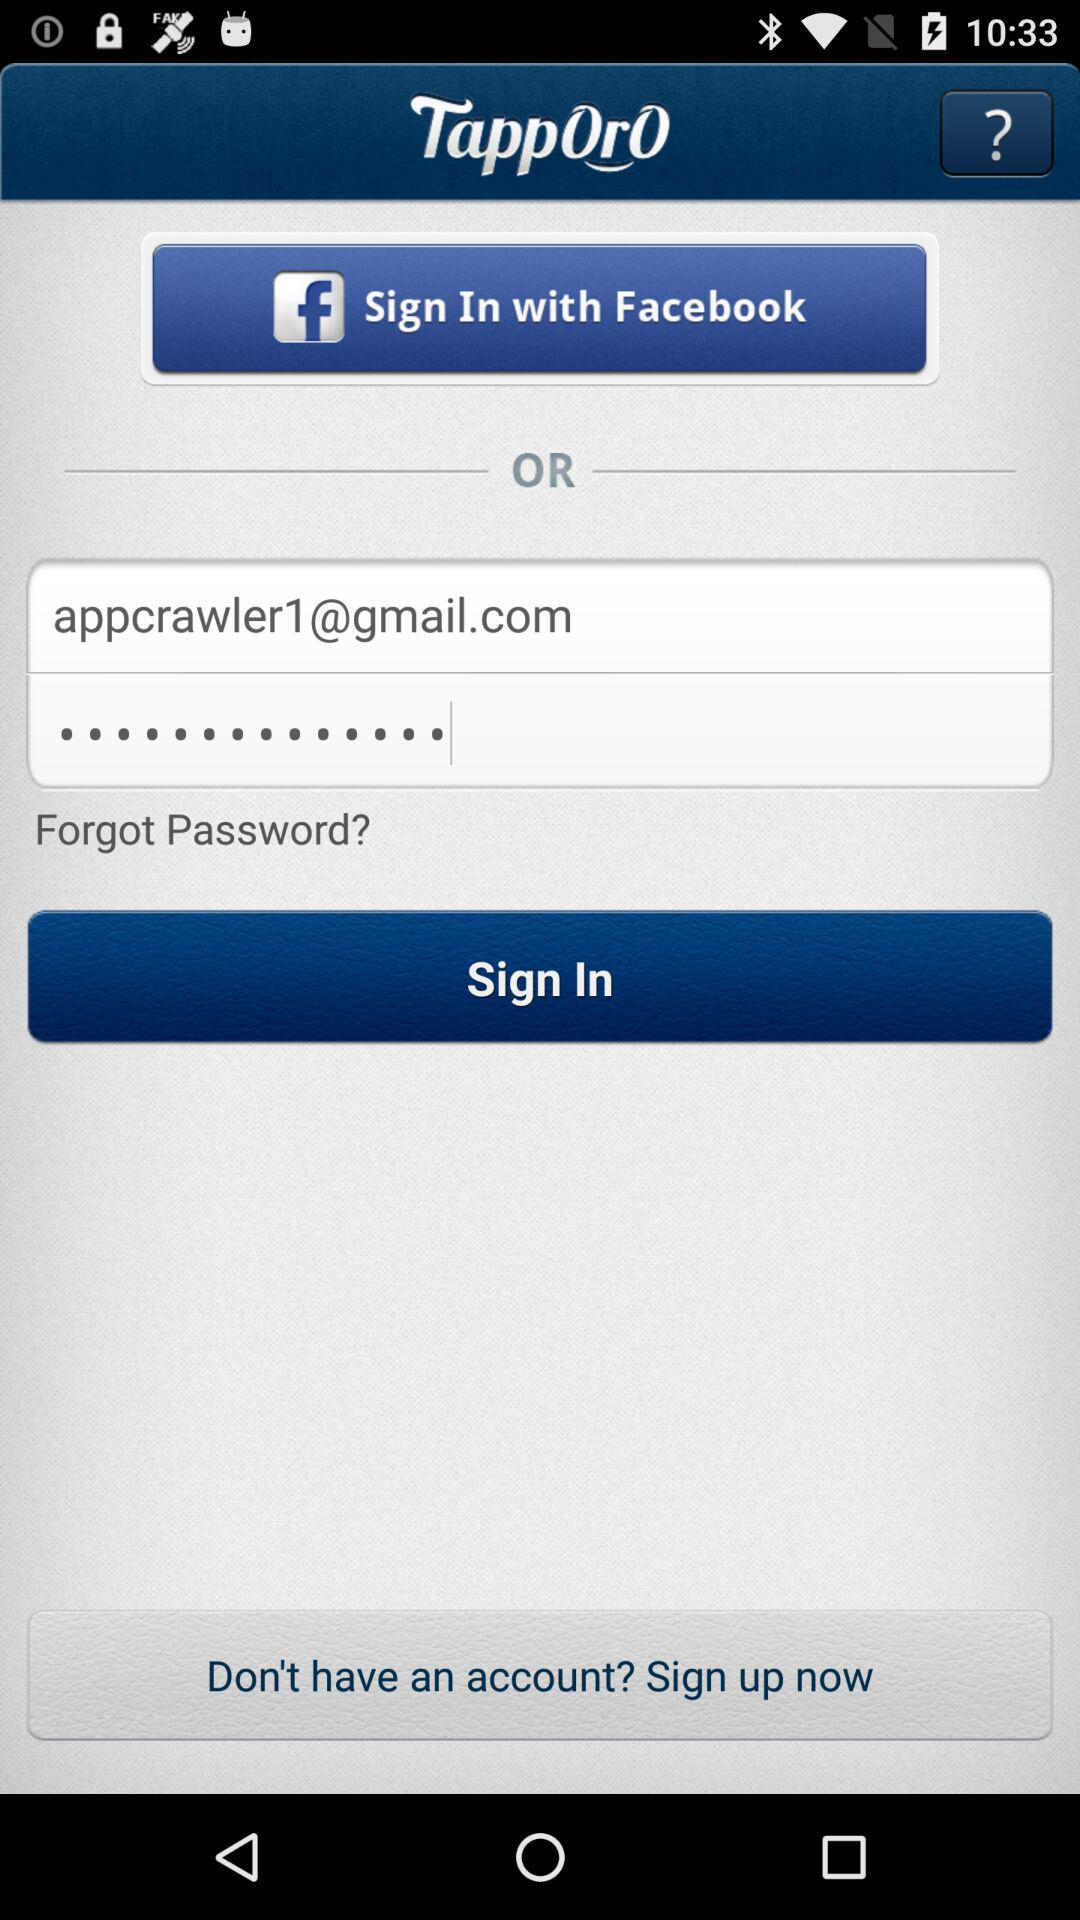How many text input fields are there on this screen?
Answer the question using a single word or phrase. 2 